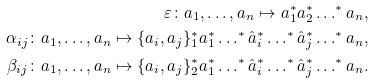Convert formula to latex. <formula><loc_0><loc_0><loc_500><loc_500>\varepsilon \colon a _ { 1 } , \dots , a _ { n } \mapsto a _ { 1 } ^ { * } a _ { 2 } ^ { * } \dots ^ { * } a _ { n } , \\ \alpha _ { i j } \colon a _ { 1 } , \dots , a _ { n } \mapsto \{ a _ { i } , a _ { j } \} _ { 1 } ^ { * } a _ { 1 } ^ { * } \dots ^ { * } \hat { a } _ { i } ^ { * } \dots ^ { * } \hat { a } _ { j } ^ { * } \dots ^ { * } a _ { n } , \\ \beta _ { i j } \colon a _ { 1 } , \dots , a _ { n } \mapsto \{ a _ { i } , a _ { j } \} _ { 2 } ^ { * } a _ { 1 } ^ { * } \dots ^ { * } \hat { a } _ { i } ^ { * } \dots ^ { * } \hat { a } _ { j } ^ { * } \dots ^ { * } a _ { n } .</formula> 